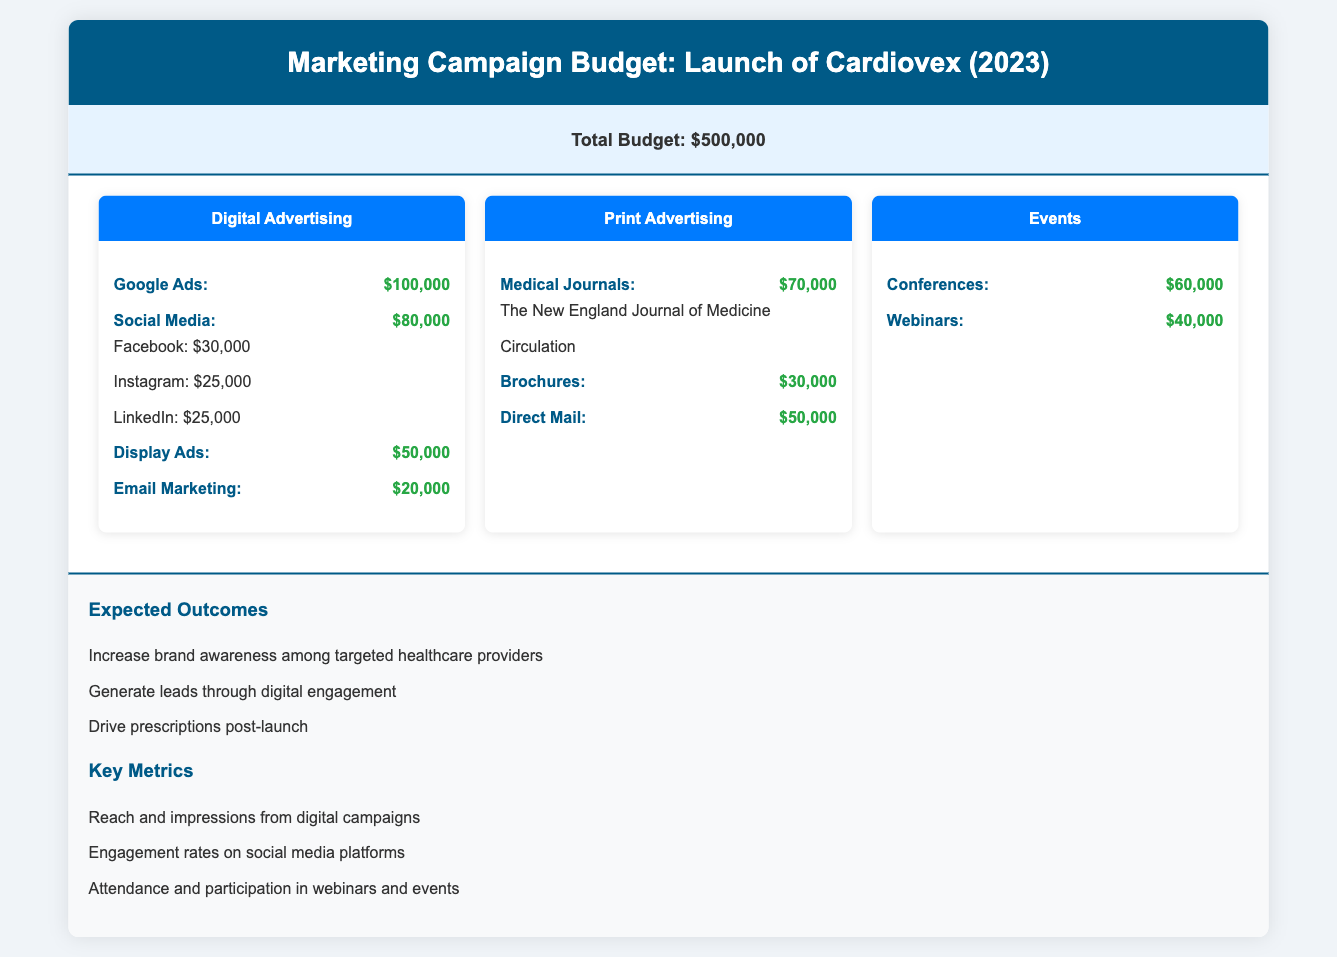What is the total budget for the campaign? The total budget is stated clearly at the top as $500,000.
Answer: $500,000 How much is allocated for Google Ads? The budget for Google Ads is specified under Digital Advertising as $100,000.
Answer: $100,000 What is the budget for Social Media ads in total? The total budget for Social Media is the sum of Facebook, Instagram, and LinkedIn, which is $30,000 + $25,000 + $25,000 = $80,000.
Answer: $80,000 Which print advertising medium has the highest budget? The medium with the highest budget under Print Advertising is Medical Journals with $70,000.
Answer: Medical Journals What is the budget allocated for Events? The total budget for Events is the sum of Conferences and Webinars, which is $60,000 + $40,000 = $100,000.
Answer: $100,000 Which platform is receiving the least amount for digital marketing? The least amount allocated in Digital Advertising is for Email Marketing, which is $20,000.
Answer: $20,000 How much is budgeted for Direct Mail? The budget for Direct Mail is specified in Print Advertising as $50,000.
Answer: $50,000 What are the expected outcomes listed in the document? The expected outcomes are clearly itemized; they include Increasing brand awareness, Generating leads, and Driving prescriptions.
Answer: Increase brand awareness among targeted healthcare providers What is one key metric mentioned for measuring the digital campaign? A key metric highlighted for the digital campaign is Reach and impressions from digital campaigns.
Answer: Reach and impressions from digital campaigns What type of document is this? The document is a budget for a marketing campaign related to the launch of a pharmaceutical product.
Answer: Marketing Campaign Budget 